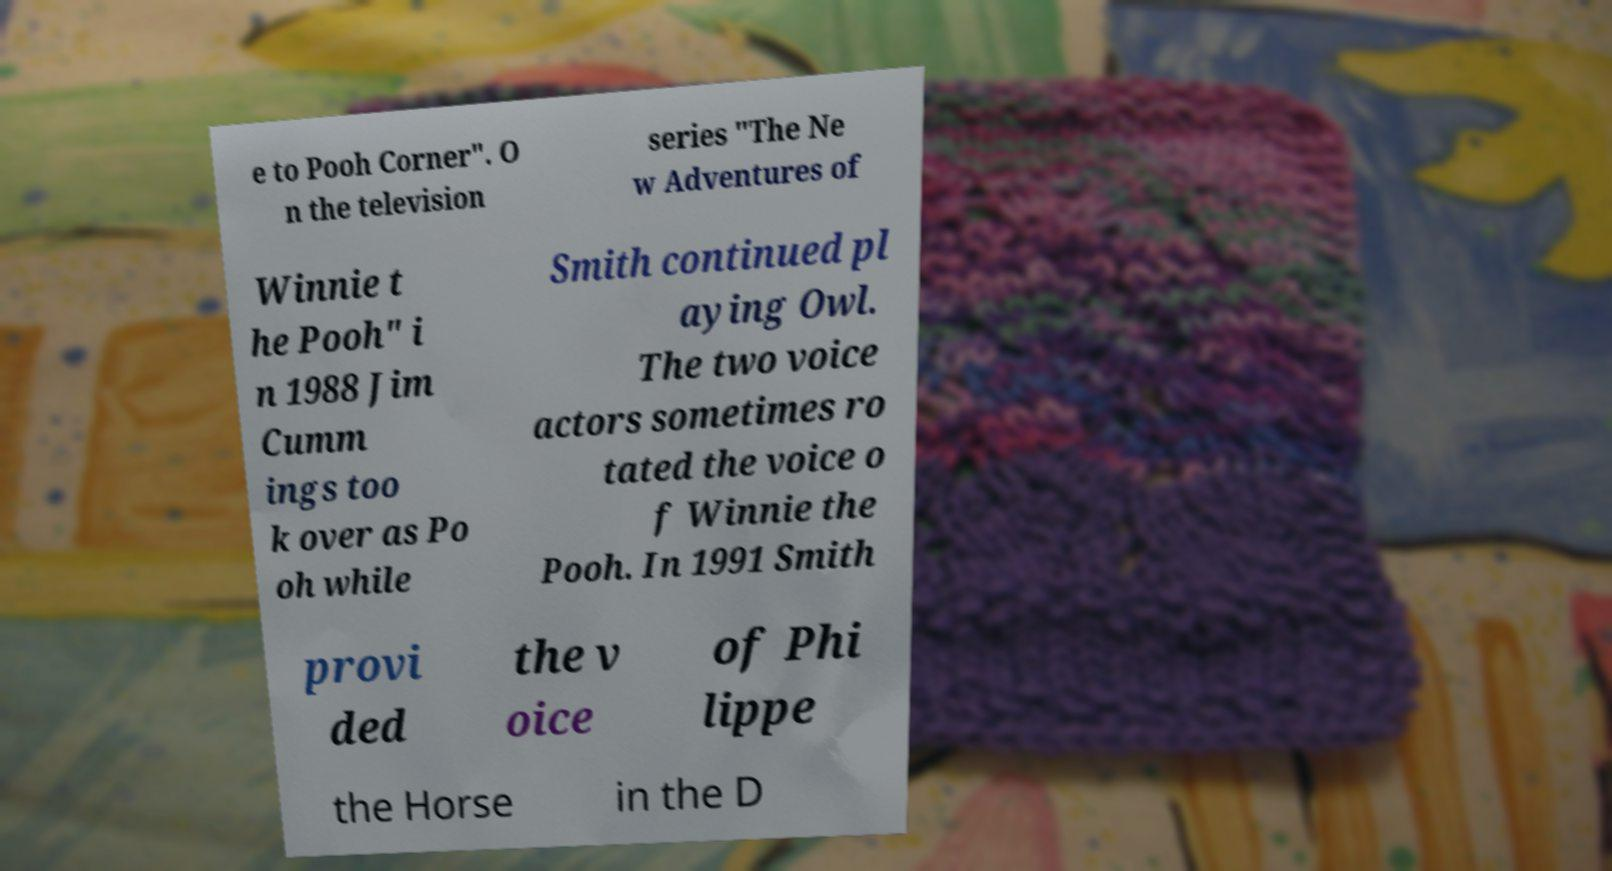Can you accurately transcribe the text from the provided image for me? e to Pooh Corner". O n the television series "The Ne w Adventures of Winnie t he Pooh" i n 1988 Jim Cumm ings too k over as Po oh while Smith continued pl aying Owl. The two voice actors sometimes ro tated the voice o f Winnie the Pooh. In 1991 Smith provi ded the v oice of Phi lippe the Horse in the D 